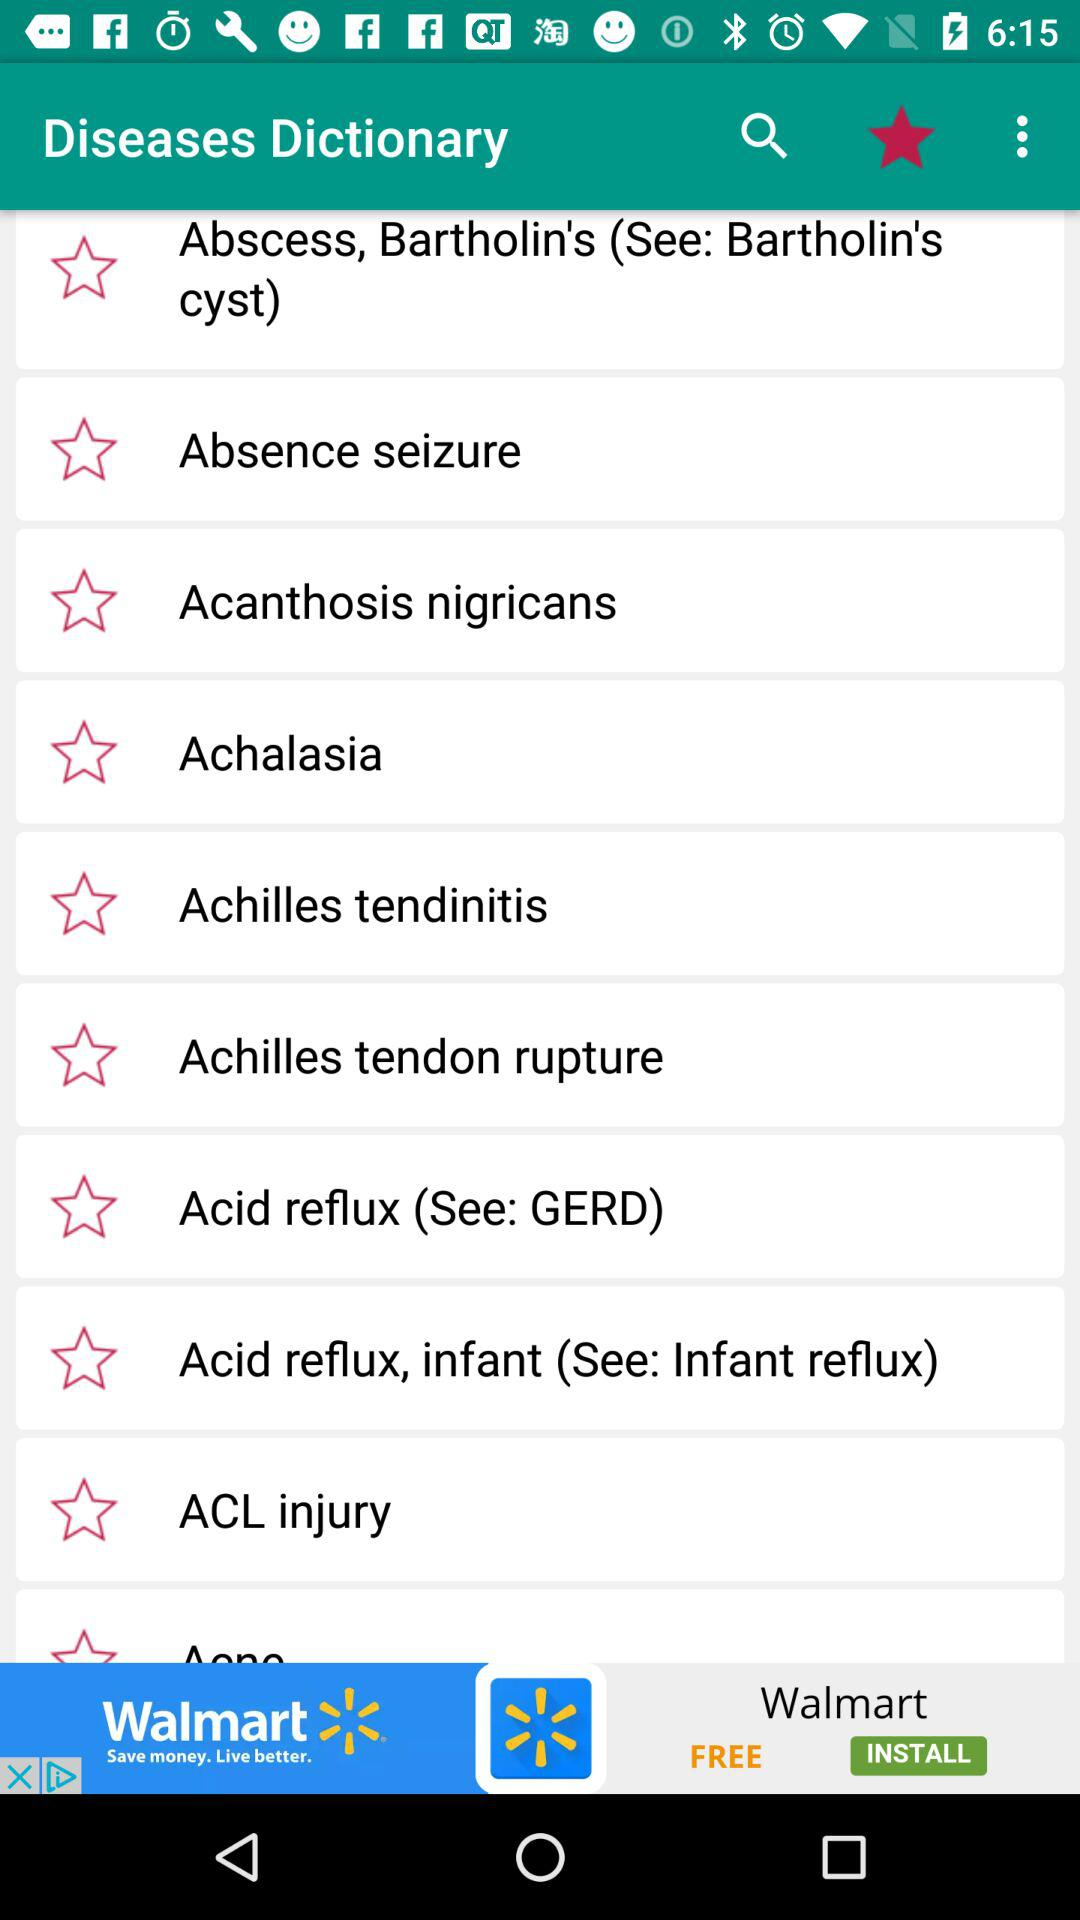What's another name of acid reflux disease? Another name of acid reflux disease is GERD. 